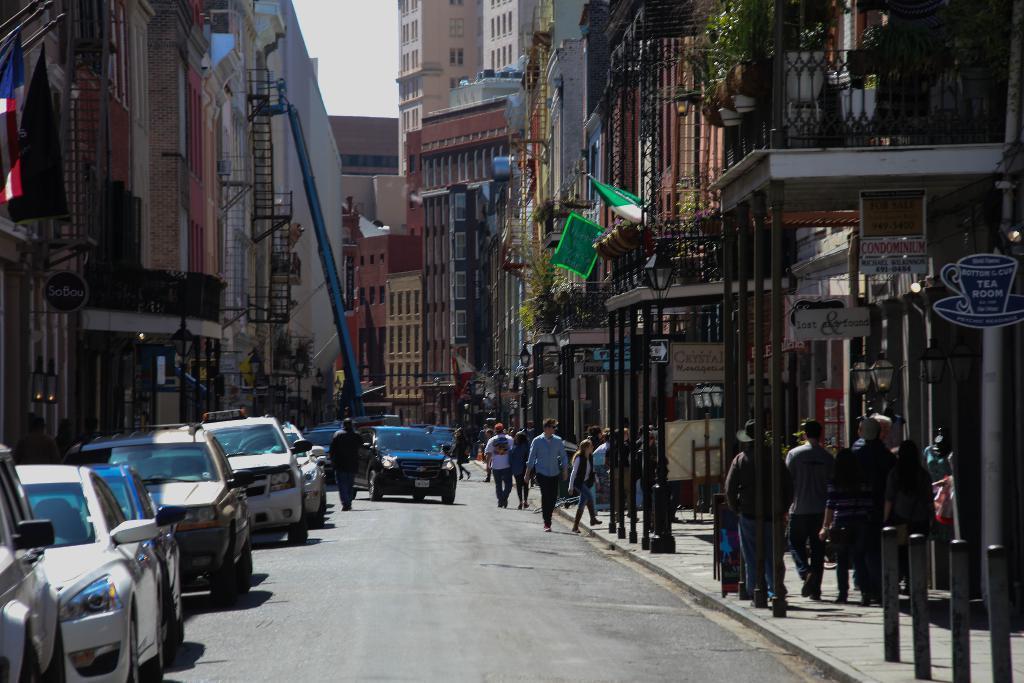In one or two sentences, can you explain what this image depicts? In this image on the left there are cars, buildings, some people. On the left there is a road. On then right there are many people walking and there are buildings, flags, posters, plants and sky. 